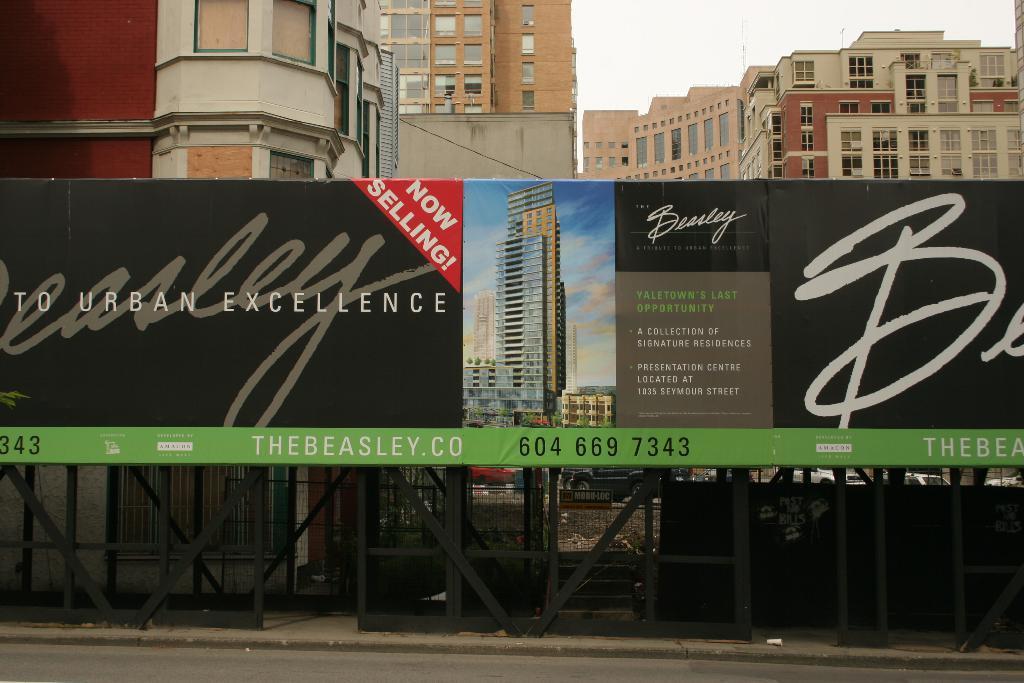In one or two sentences, can you explain what this image depicts? In this picture we can see a hoarding in the front, there is some text, numbers and picture of buildings on the hoarding, in the background there are some buildings, we can see the sky at the top of the picture. 